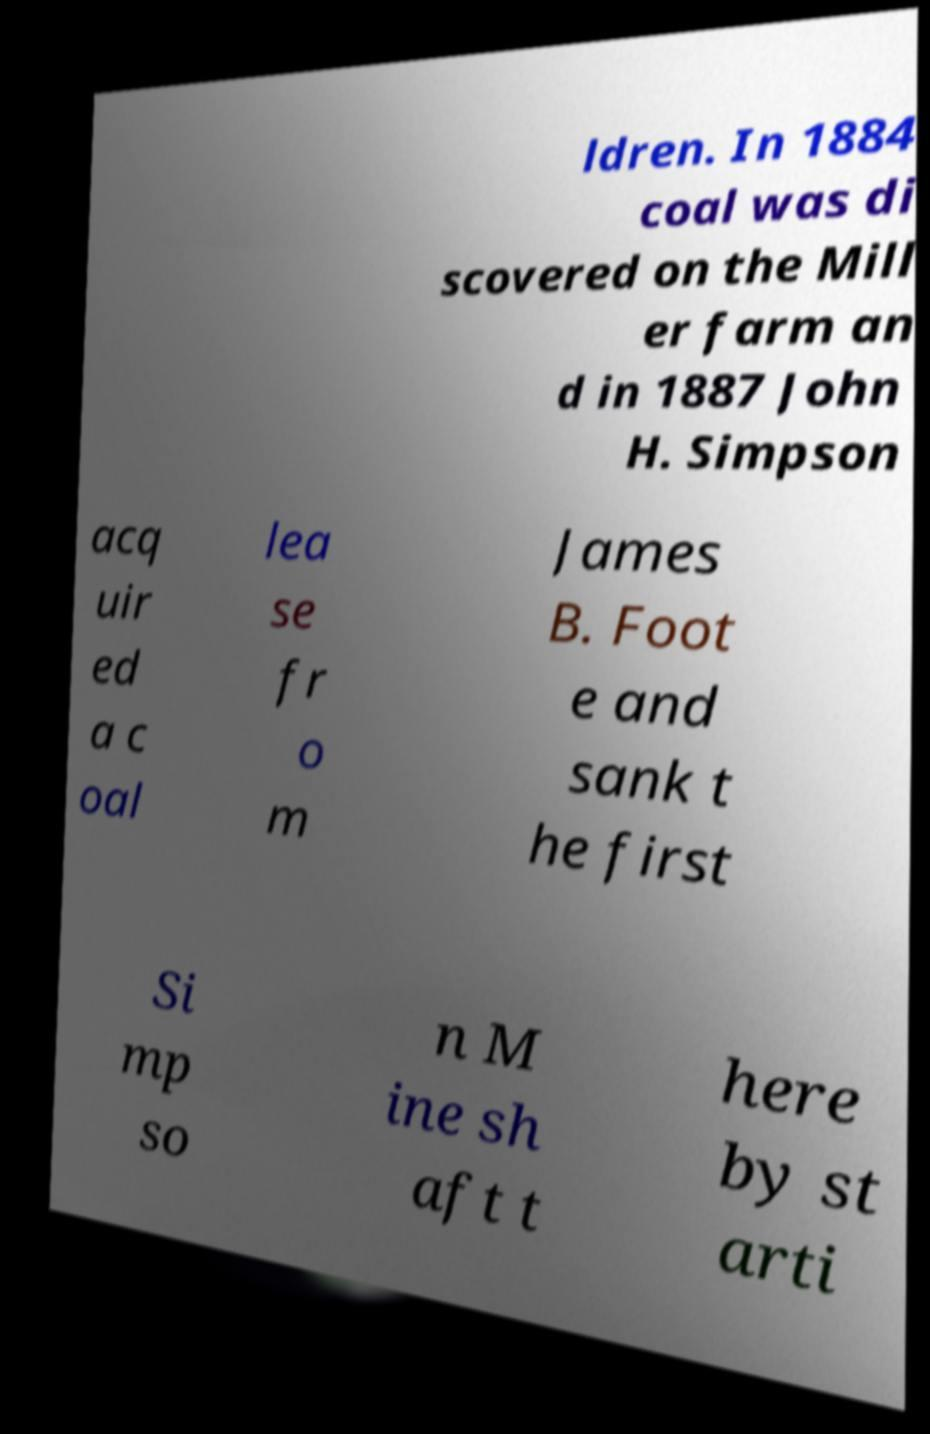Can you accurately transcribe the text from the provided image for me? ldren. In 1884 coal was di scovered on the Mill er farm an d in 1887 John H. Simpson acq uir ed a c oal lea se fr o m James B. Foot e and sank t he first Si mp so n M ine sh aft t here by st arti 